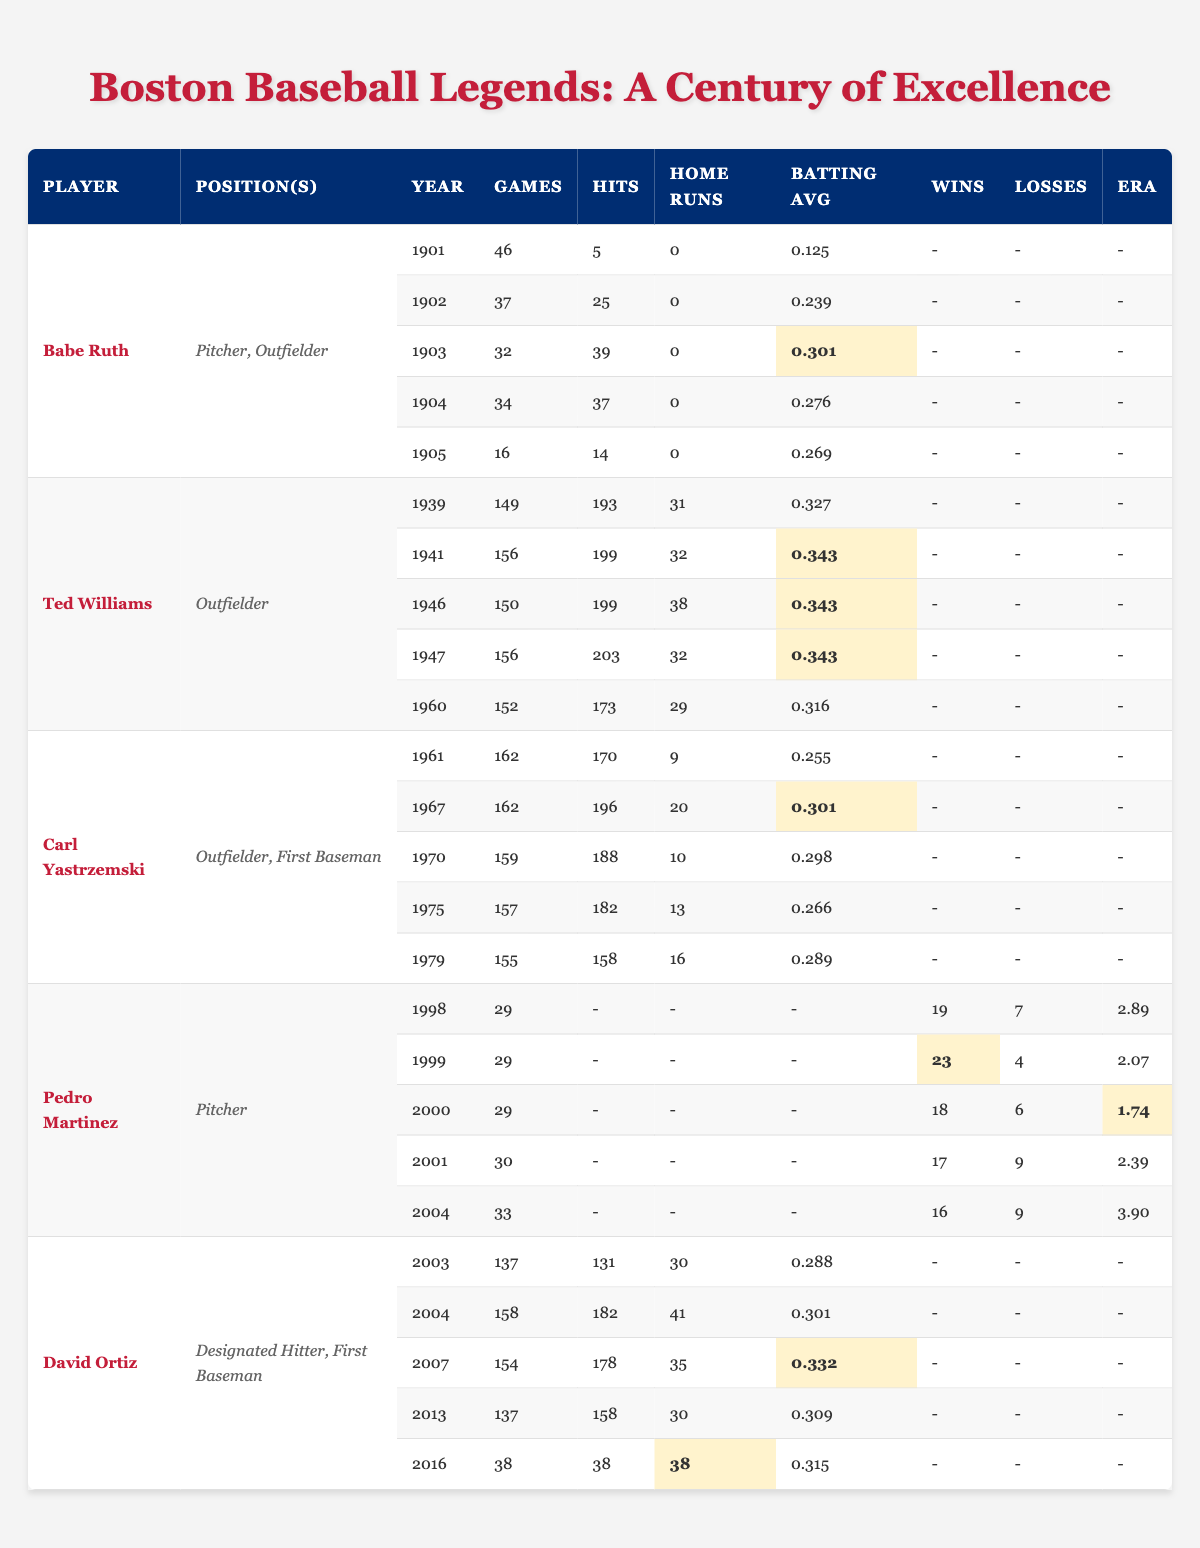What player had the highest batting average in 1946? By examining the table, Ted Williams has a batting average of 0.343 in 1946, which is listed under his data. This is the highest value among players in that year.
Answer: 0.343 How many home runs did David Ortiz hit in 2004? The table shows that David Ortiz hit 41 home runs in 2004, which is clearly listed in his row data for that year.
Answer: 41 Which player played the most games in a season and how many? The table lists the number of games played by all players. Ted Williams played 156 games in both 1941 and 1947, which is the highest recorded.
Answer: 156 Did Carl Yastrzemski have a batting average over 0.300 in 1967? In 1967, Carl Yastrzemski had a batting average of 0.301, as stated in his statistics, confirming he did surpass 0.300 that season.
Answer: Yes What is the total number of games played by Pedro Martinez in his best year? Pedro Martinez played 29 games each in 1998, 1999, and 2000, but 30 games in 2001, and 33 games in 2004. The highest total is 33 games in 2004.
Answer: 33 How many home runs did Ted Williams hit across his listed seasons? By adding Ted Williams' home runs from each relevant year: 31 + 32 + 38 + 32 + 29 = 162. Thus, the total is 162 home runs across these seasons.
Answer: 162 In which year did Babe Ruth have his best batting average? In 1903, Babe Ruth had his best batting average of 0.301 as shown in the season data. This is higher than his averages for the other years listed.
Answer: 1903 Which player had the lowest number of hits in a single season, and how many were they? Babe Ruth has the least hits in 1901 with only 5 hits. This is the lowest figure visible in the table for all players and years.
Answer: 5 What is the average number of home runs per season for David Ortiz based on the listed years? To find the average, count the home runs he hit: 30 + 41 + 35 + 30 + 38 = 174. Dividing this total by the 5 seasons listed gives an average of 34.8.
Answer: 34.8 Did any player have an era of less than 2.00? Yes, Pedro Martinez had an era of 1.74 in 2000, which is less than 2.00, according to his statistics in the table.
Answer: Yes 